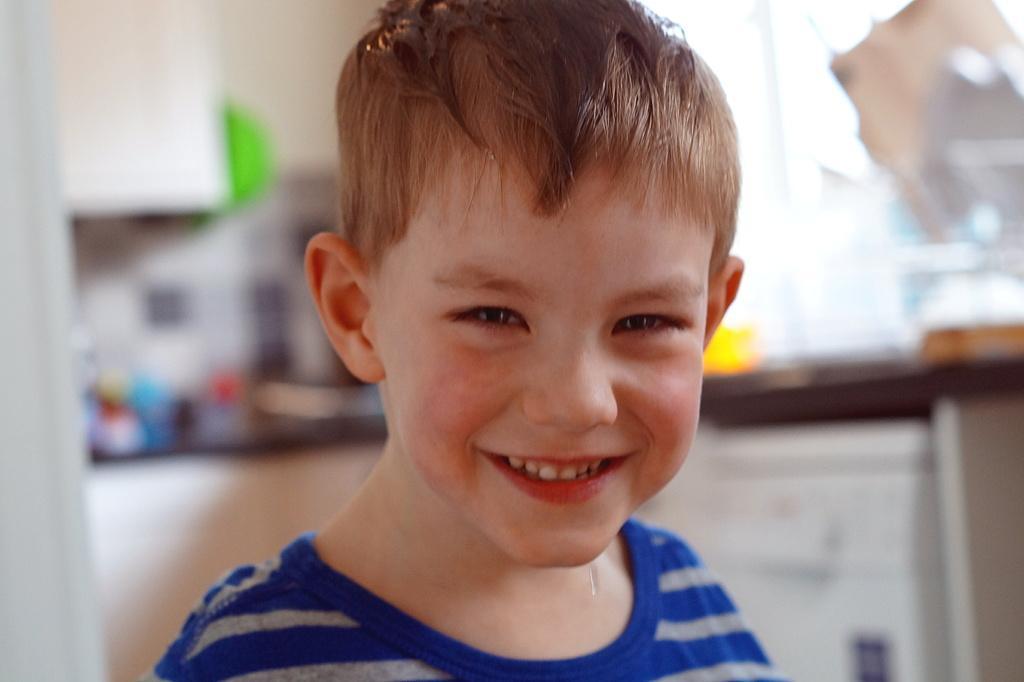Describe this image in one or two sentences. In the image a kid is standing and smiling. Behind him there is a table and the background of the image is blur. 